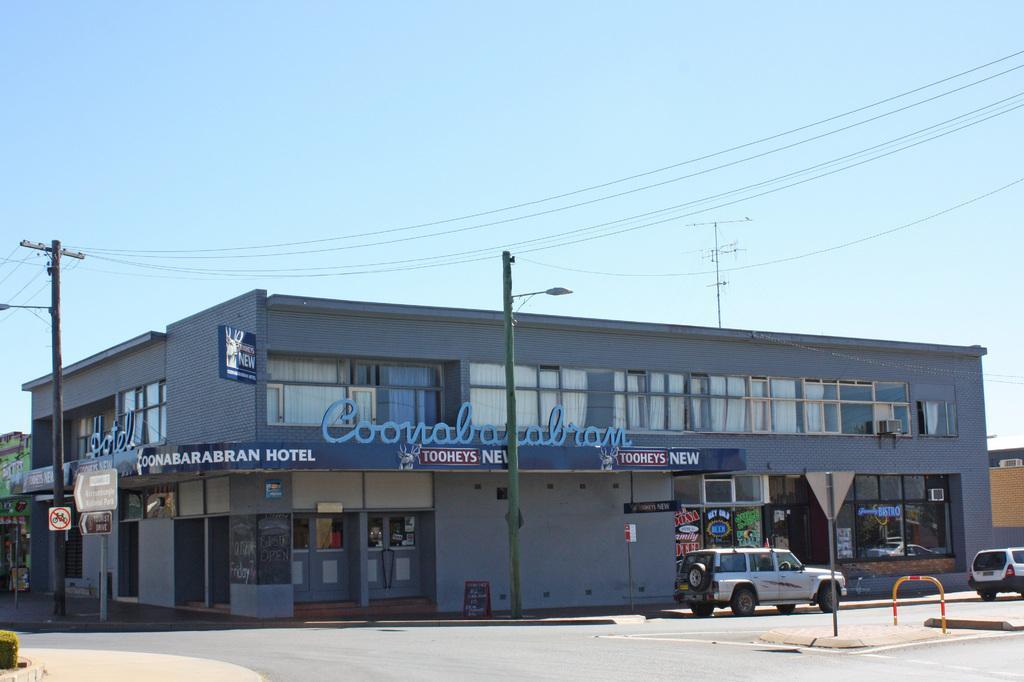How would you summarize this image in a sentence or two? In this picture we can observe a building which is in blue color. There are two poles. We can observe two vehicles on the road. There are some wires. In the background there is a sky. 